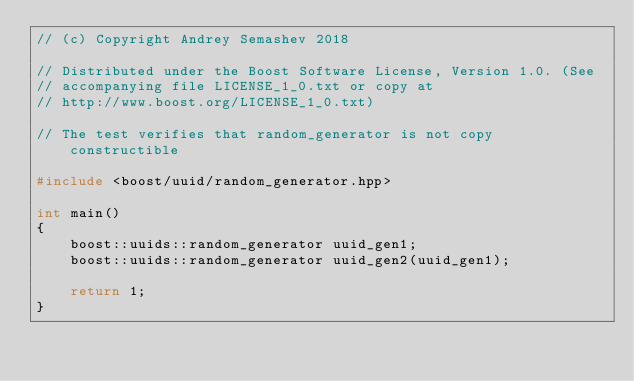<code> <loc_0><loc_0><loc_500><loc_500><_C++_>// (c) Copyright Andrey Semashev 2018

// Distributed under the Boost Software License, Version 1.0. (See
// accompanying file LICENSE_1_0.txt or copy at
// http://www.boost.org/LICENSE_1_0.txt)

// The test verifies that random_generator is not copy constructible

#include <boost/uuid/random_generator.hpp>

int main()
{
    boost::uuids::random_generator uuid_gen1;
    boost::uuids::random_generator uuid_gen2(uuid_gen1);

    return 1;
}
</code> 